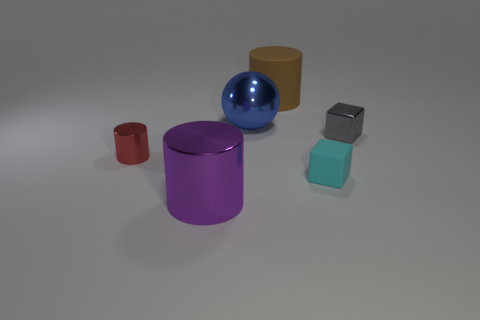There is a cylinder that is the same size as the gray cube; what is its material?
Ensure brevity in your answer.  Metal. Are there any metal balls that have the same size as the brown thing?
Your response must be concise. Yes. What color is the tiny cylinder?
Make the answer very short. Red. What is the color of the tiny thing right of the rubber thing right of the large brown thing?
Give a very brief answer. Gray. The large metal thing that is left of the metal thing that is behind the cube behind the small cyan rubber block is what shape?
Provide a short and direct response. Cylinder. What number of cylinders are made of the same material as the tiny cyan cube?
Your answer should be very brief. 1. There is a tiny object that is to the right of the small rubber thing; what number of small gray metallic blocks are behind it?
Offer a terse response. 0. How many red shiny things are there?
Ensure brevity in your answer.  1. Do the brown cylinder and the cylinder in front of the red metallic cylinder have the same material?
Offer a terse response. No. There is a metal cylinder that is in front of the tiny cyan object; is its color the same as the small cylinder?
Your answer should be compact. No. 